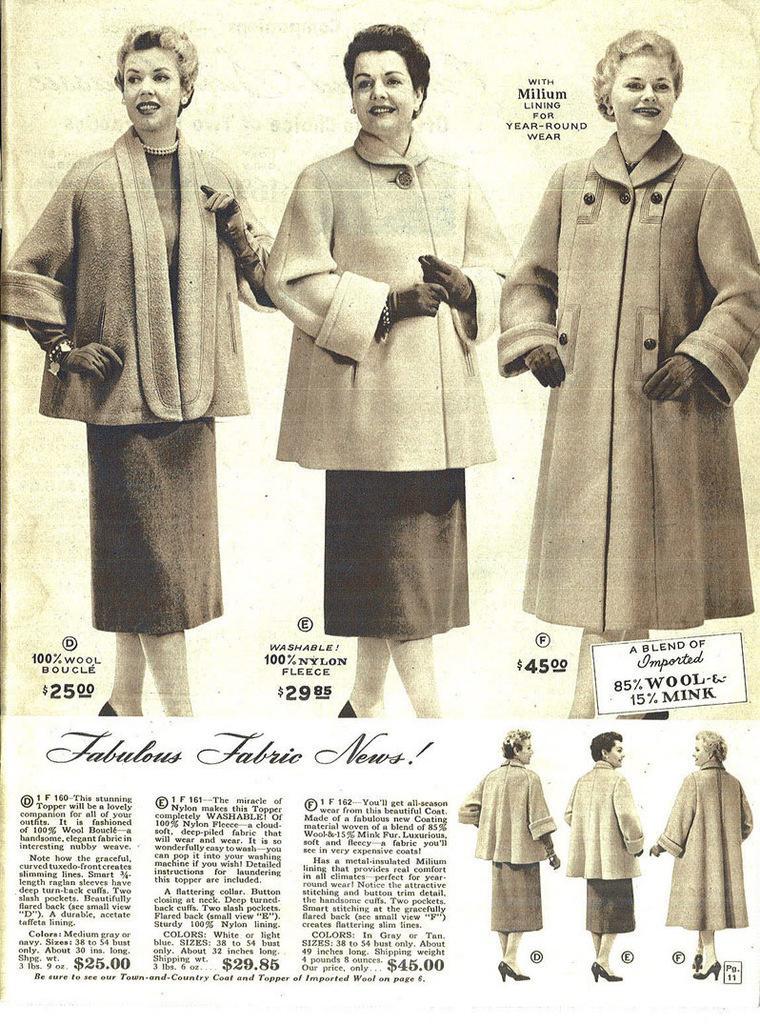Could you give a brief overview of what you see in this image? In this image we can see a paper and the pictures of women. 